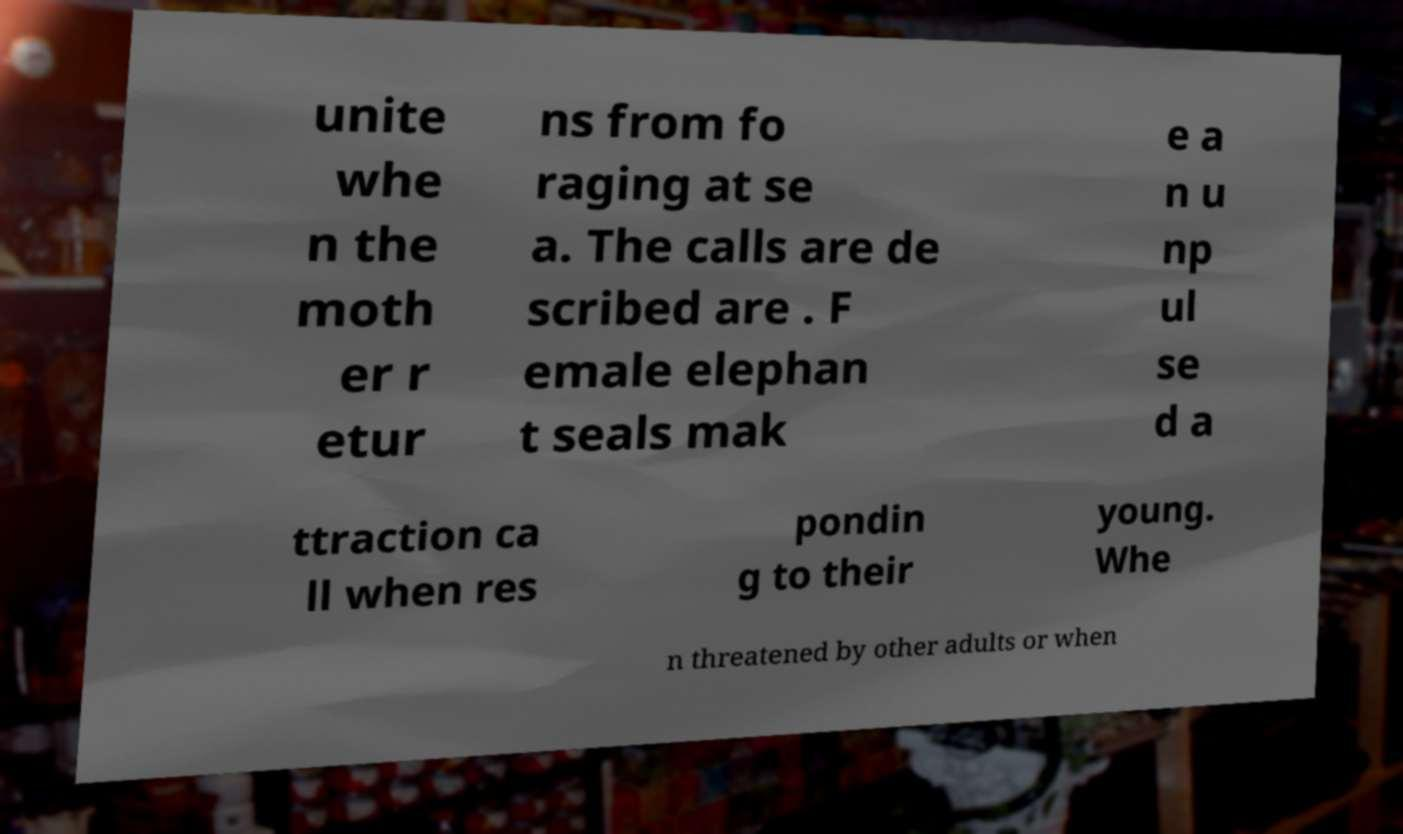What messages or text are displayed in this image? I need them in a readable, typed format. unite whe n the moth er r etur ns from fo raging at se a. The calls are de scribed are . F emale elephan t seals mak e a n u np ul se d a ttraction ca ll when res pondin g to their young. Whe n threatened by other adults or when 